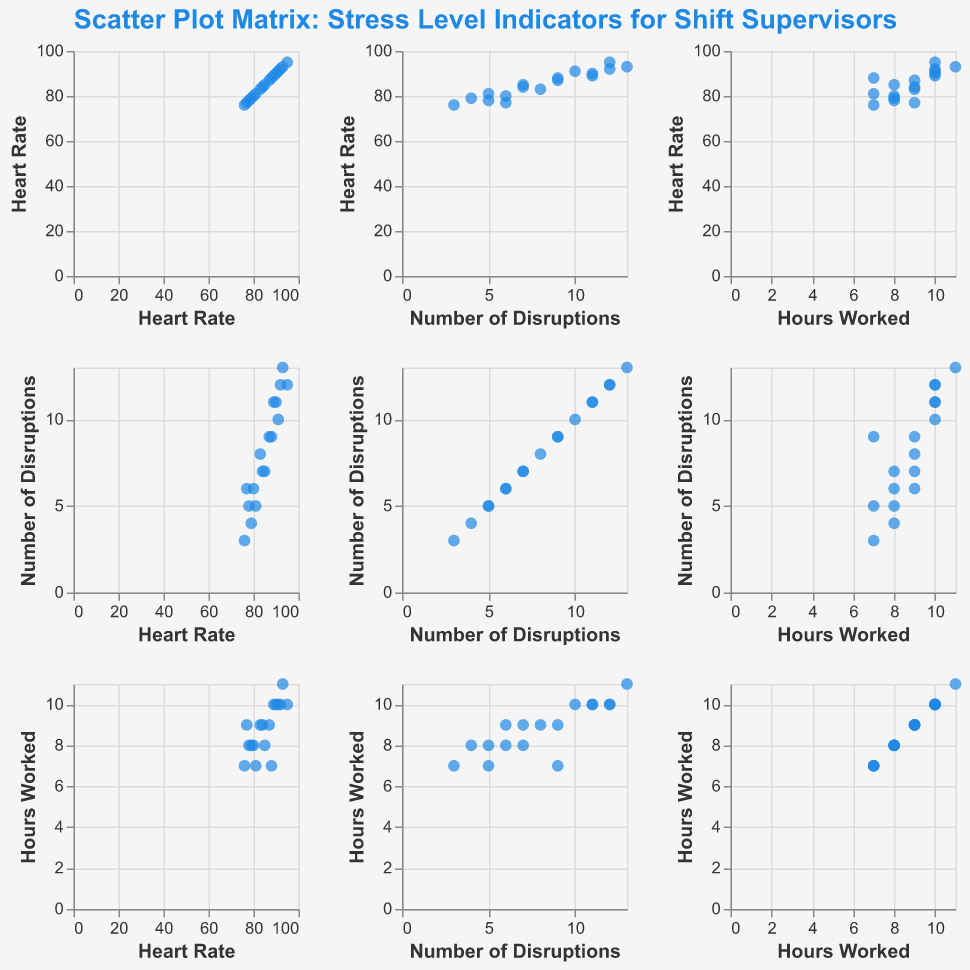What is the title of the scatter plot matrix? The title of the plot is usually placed at the top. By looking at the top of the scatter plot matrix, we can easily find the title.
Answer: "Scatter Plot Matrix: Stress Level Indicators for Shift Supervisors" How many data points are present in the scatter plot matrix? Each point represents a combination of different values for Heart Rate, Number of Disruptions, and Hours Worked. Count the points in one of the individual scatter plots.
Answer: 17 What is the color used for the data points in the scatter plot matrix? By looking at the scatter plot matrix, we can see the color of the data points. In this case, they are all of a single color.
Answer: Blue Which variables are plotted along the x-axis and y-axis? The scatter plot matrix shows different variables on both the x and y axes, rotating through the Heart Rate, Number of Disruptions, and Hours Worked. Each row and column represents one of these variables.
Answer: Heart Rate, Number of Disruptions, Hours Worked Which pair of variables shows the most clustered pattern? By comparing different scatter plots in the matrix, look for the pairs where the data points are closest to one another, indicating a more clustered pattern.
Answer: "Heart Rate" and "Number of Disruptions" Is there a visible trend between Heart Rate and Hours Worked? Compare the scatter plots with Heart Rate on one axis and Hours Worked on the other. Look for any patterns such as an upward or downward trend.
Answer: Yes, an upward trend Which pair shows the highest positive correlation? Observe the scatter plots for a pattern where the dots are closely packed along an upward diagonal line; this indicates a high positive correlation.
Answer: "Heart Rate" and "Number of Disruptions" Are there any data points where the Heart Rate is above 90 and the Number of Disruptions is above 10? Look at the scatter plot where Heart Rate is plotted against Number of Disruptions. Count the points where Heart Rate > 90 and Number of Disruptions > 10.
Answer: Yes, there are two data points Which variable appears to have the highest variability and how can you tell? Variability can be visualized through the scatter plots and the spread of points. The variable with the most spread (or widest range) indicates highest variability.
Answer: "Number of Disruptions" Do individuals working 9 hours show a high heart rate compared to those working 7 hours? Compare the scatter plots with "Hours Worked" against "Heart Rate" and look for the distribution of Heart Rates at 7 hours vs. 9 hours.
Answer: Those working 9 hours generally have a higher Heart Rate than those working 7 hours 